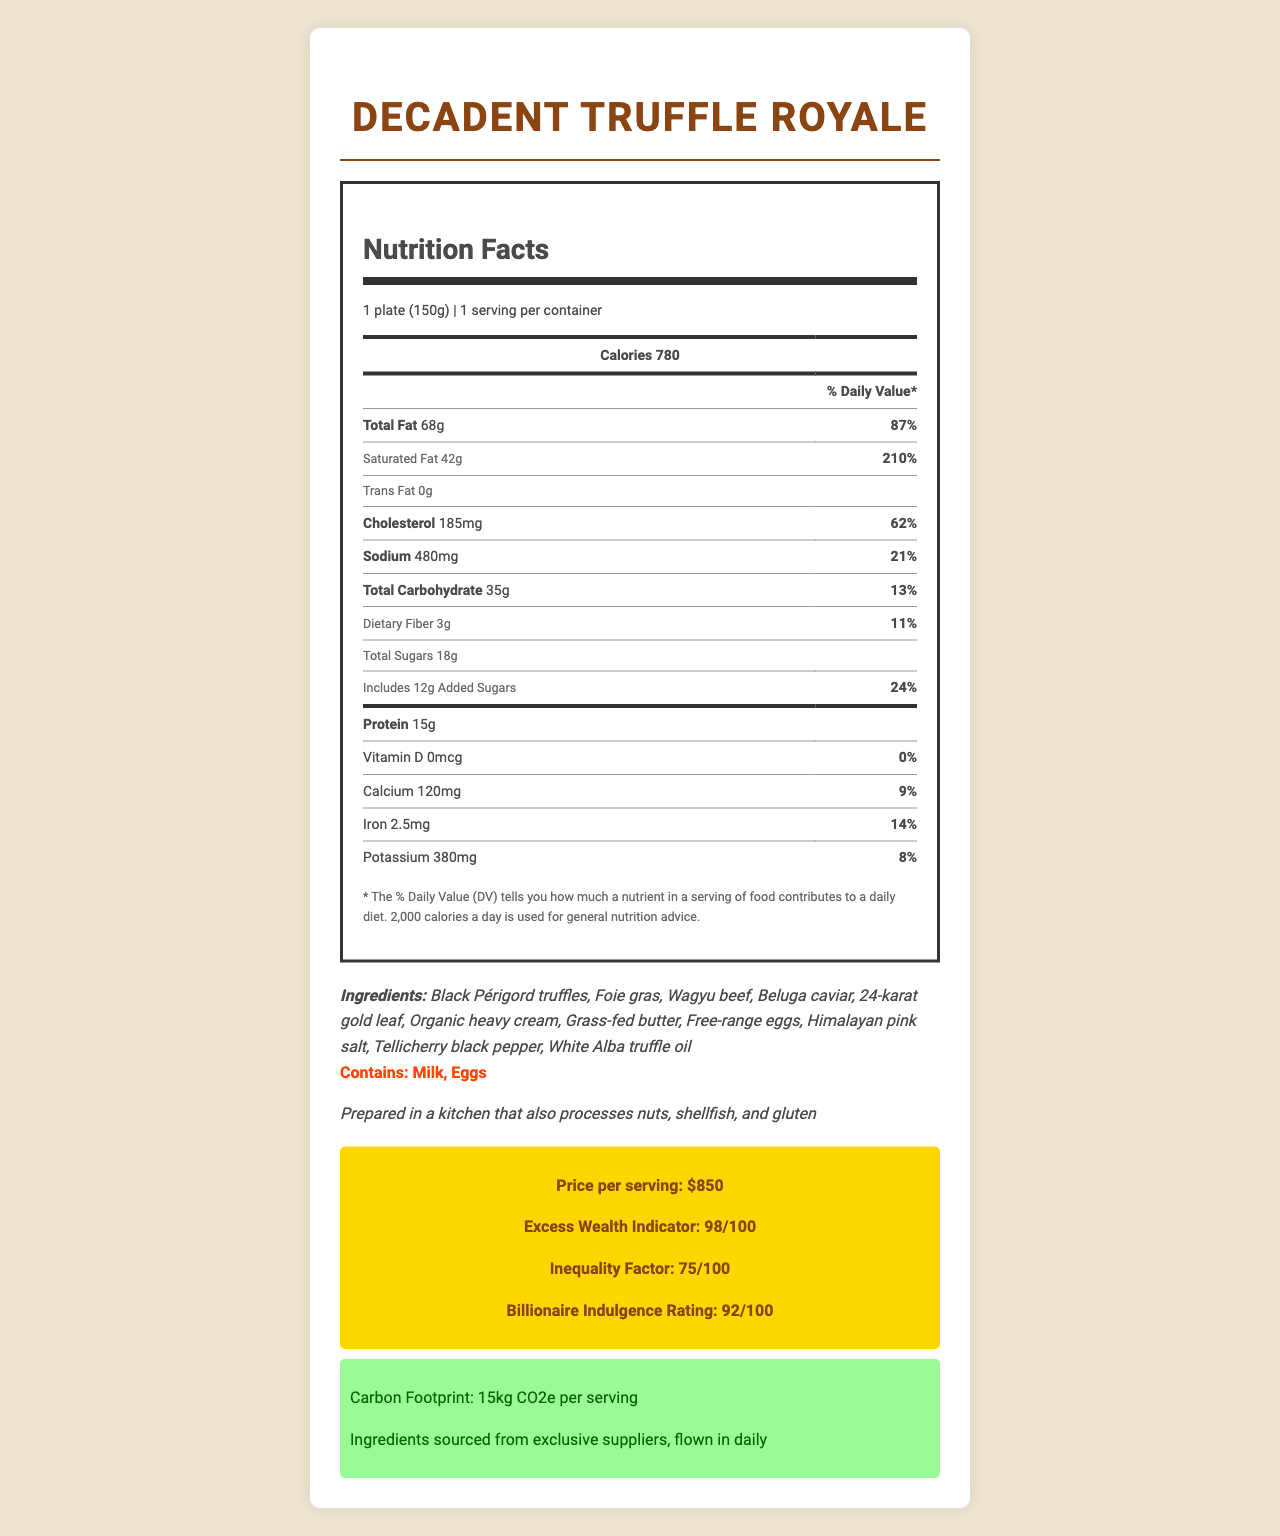what is the product name? The product name is listed at the top of the document.
Answer: Decadent Truffle Royale what is the serving size of the Decadent Truffle Royale? The serving size is specified as "1 plate (150g)" on the Nutrition Facts label.
Answer: 1 plate (150g) how many calories are in one serving? The calories per serving are listed prominently as 780.
Answer: 780 how much total fat is in one serving? The total fat per serving is mentioned as 68g.
Answer: 68g how much protein is in the Decadent Truffle Royale? The amount of protein per serving is listed as 15g.
Answer: 15g What ingredient is not listed in the Decadent Truffle Royale?  
A. Black Périgord truffles  
B. Wagyu beef  
C. Organic salmon  
D. Free-range eggs The ingredient list includes Black Périgord truffles, Wagyu beef, and Free-range eggs, but not Organic salmon.
Answer: C What is the Excess Wealth Indicator of the Decadent Truffle Royale?  
I. 85  
II. 90  
III. 92  
IV. 98 The Excess Wealth Indicator is noted as 98.
Answer: IV Does the Decadent Truffle Royale contain any allergens? (Yes/No) The allergens are listed as "Milk" and "Eggs".
Answer: Yes What is the main content of this document? The document provides detailed nutritional information, ingredient and allergen listings, and some indicators about the price, wealth, and sustainability related to the dish.
Answer: Overview of the nutritional facts and ingredients of a gourmet truffle-based dish called Decadent Truffle Royale. What is the cost per serving of this dish? The cost per serving is explicitly mentioned as $850.
Answer: $850 What is the preparation note for this dish? The preparation note states that the dish is prepared in a kitchen that processes nuts, shellfish, and gluten.
Answer: Prepared in a kitchen that also processes nuts, shellfish, and gluten What is the total amount of daily value percentage for Saturated Fat and Cholesterol combined? The saturated fat is 210% and cholesterol is 62%, totalling to 272%.
Answer: 272% What is the serving size of Decadent Truffle Royale in servings per container? The document doesn't provide enough detailed information to determine the exact serving size in servings per container.
Answer: Cannot be determined What is the sustainability note about the ingredients? The sustainability note specifically mentions the ingredients are sourced from exclusive suppliers and flown in daily.
Answer: Ingredients sourced from exclusive suppliers, flown in daily How much is the carbon footprint per serving of Decadent Truffle Royale? The carbon footprint per serving is listed as 15kg CO2e per serving.
Answer: 15kg CO2e per serving What are the types of truffles mentioned in the ingredients? The ingredients include Black Périgord truffles and White Alba truffle oil.
Answer: Black Périgord truffles and White Alba truffle oil What is the dietary fiber content per serving, and what percentage of the daily value does it represent? The dietary fiber content is 3g, which represents 11% of the daily value.
Answer: 3g, 11% 